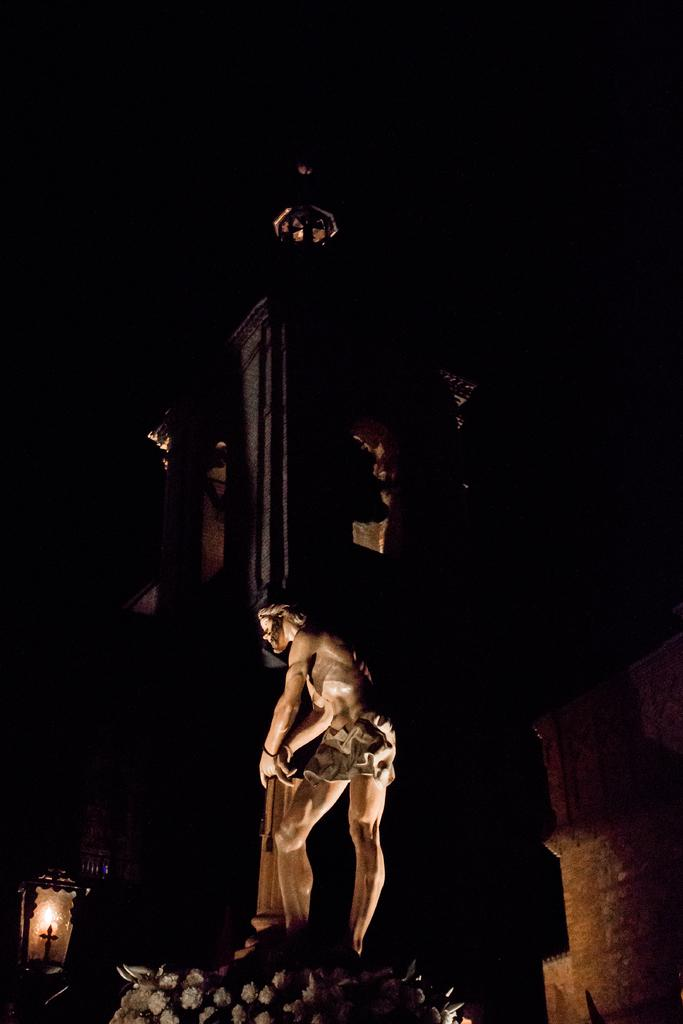What is the main subject of the image? There is a statue of a person in the image. What object can be seen on the left side of the image? There is a candle on the left side of the image. How would you describe the overall lighting in the image? The background of the image is dark. How many flies can be seen on the statue's face in the image? There are no flies present on the statue's face in the image. What type of appliance is visible near the statue in the image? There is no appliance visible near the statue in the image. 